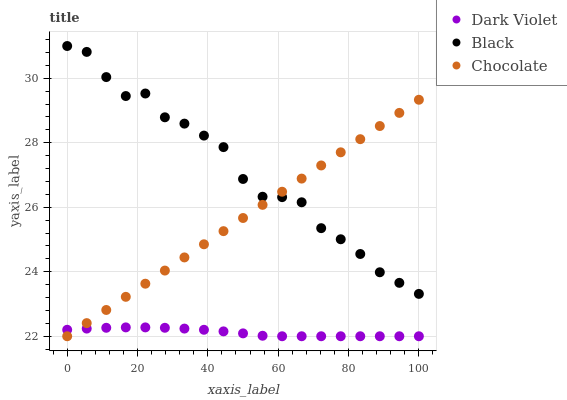Does Dark Violet have the minimum area under the curve?
Answer yes or no. Yes. Does Black have the maximum area under the curve?
Answer yes or no. Yes. Does Chocolate have the minimum area under the curve?
Answer yes or no. No. Does Chocolate have the maximum area under the curve?
Answer yes or no. No. Is Chocolate the smoothest?
Answer yes or no. Yes. Is Black the roughest?
Answer yes or no. Yes. Is Dark Violet the smoothest?
Answer yes or no. No. Is Dark Violet the roughest?
Answer yes or no. No. Does Dark Violet have the lowest value?
Answer yes or no. Yes. Does Black have the highest value?
Answer yes or no. Yes. Does Chocolate have the highest value?
Answer yes or no. No. Is Dark Violet less than Black?
Answer yes or no. Yes. Is Black greater than Dark Violet?
Answer yes or no. Yes. Does Black intersect Chocolate?
Answer yes or no. Yes. Is Black less than Chocolate?
Answer yes or no. No. Is Black greater than Chocolate?
Answer yes or no. No. Does Dark Violet intersect Black?
Answer yes or no. No. 